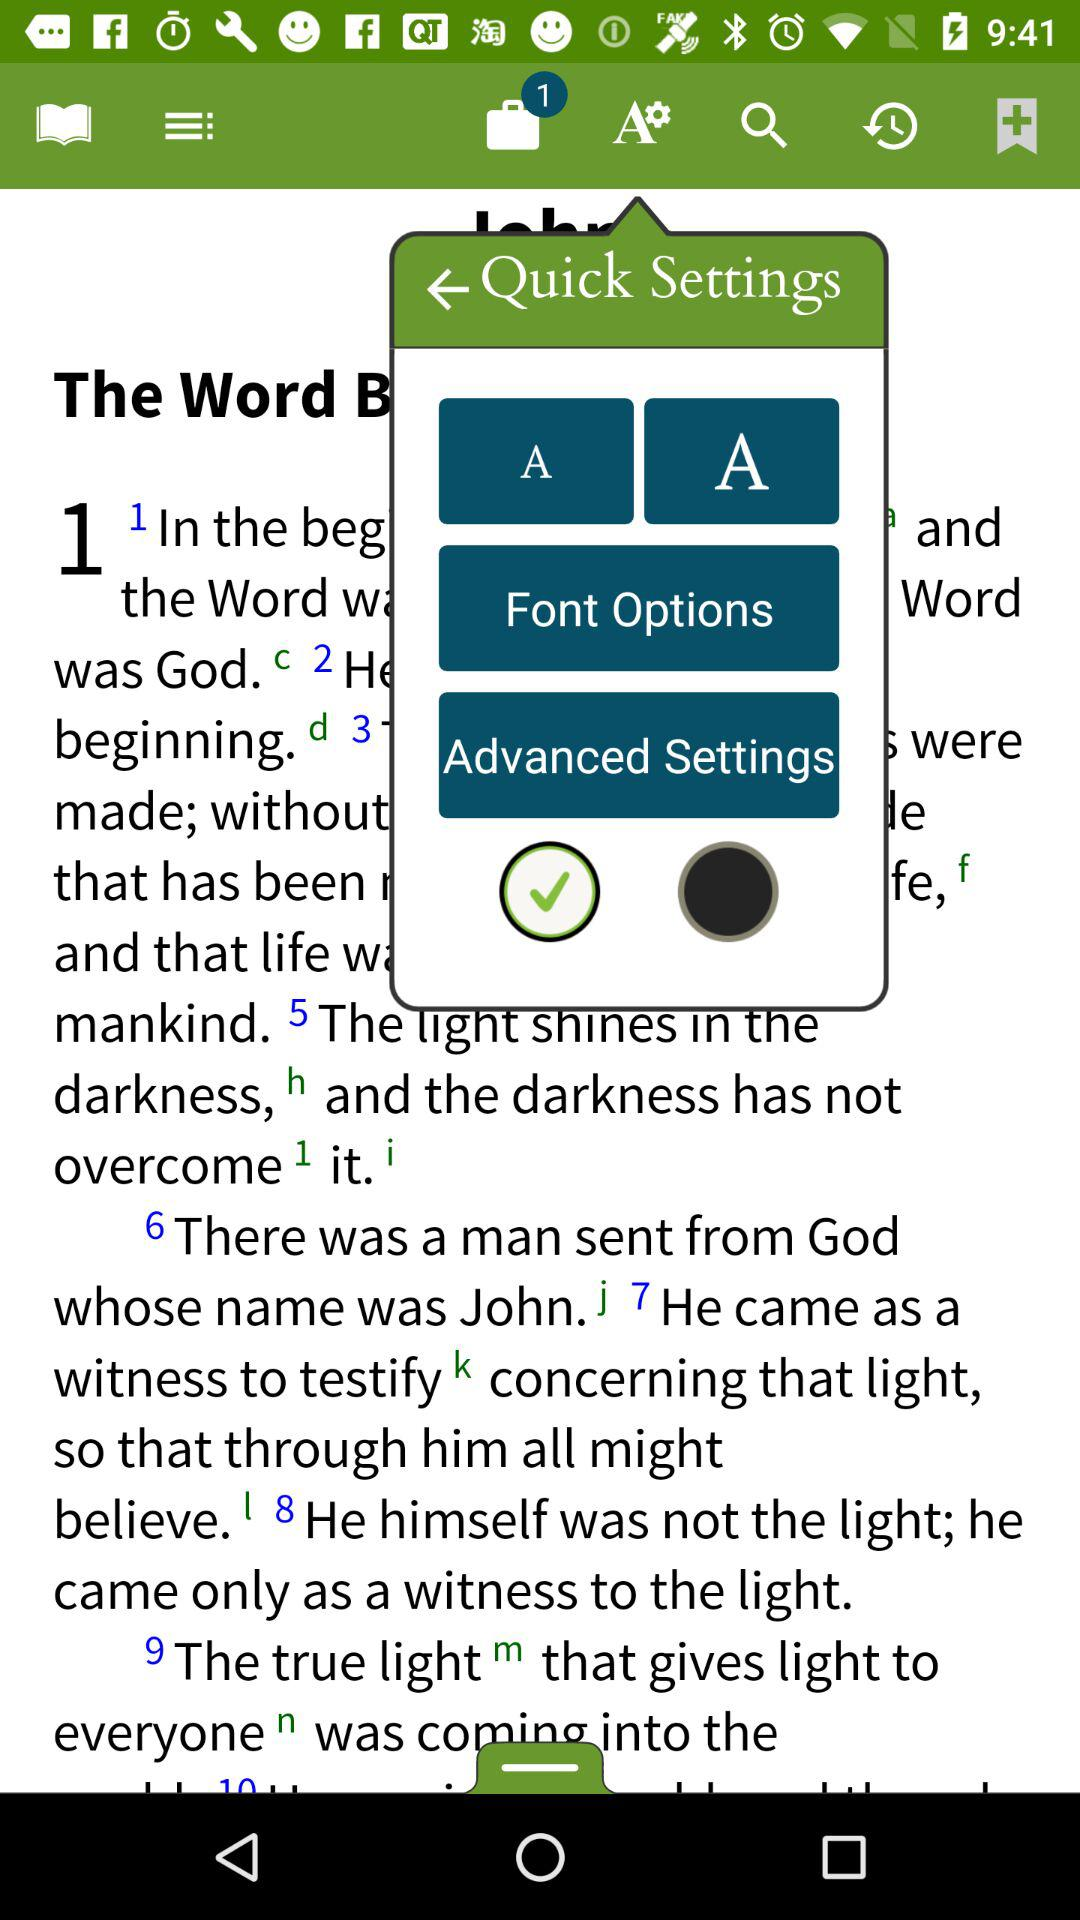How many new notifications are there? There is 1 new notification. 